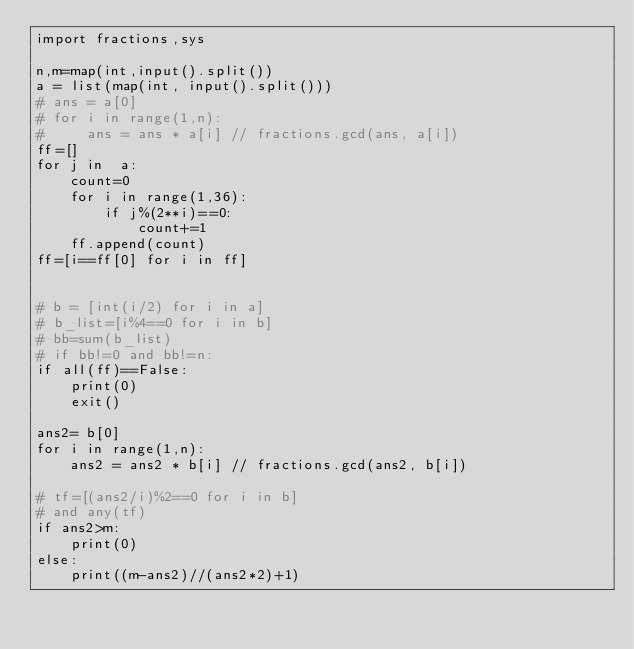<code> <loc_0><loc_0><loc_500><loc_500><_Python_>import fractions,sys

n,m=map(int,input().split())
a = list(map(int, input().split()))
# ans = a[0]
# for i in range(1,n):
#     ans = ans * a[i] // fractions.gcd(ans, a[i])
ff=[]
for j in  a:
    count=0
    for i in range(1,36):
        if j%(2**i)==0:
            count+=1
    ff.append(count)
ff=[i==ff[0] for i in ff]

 
# b = [int(i/2) for i in a]
# b_list=[i%4==0 for i in b]
# bb=sum(b_list)
# if bb!=0 and bb!=n:
if all(ff)==False:
    print(0)
    exit()

ans2= b[0]
for i in range(1,n):
    ans2 = ans2 * b[i] // fractions.gcd(ans2, b[i])

# tf=[(ans2/i)%2==0 for i in b]
# and any(tf)
if ans2>m:
    print(0)
else:
    print((m-ans2)//(ans2*2)+1)</code> 